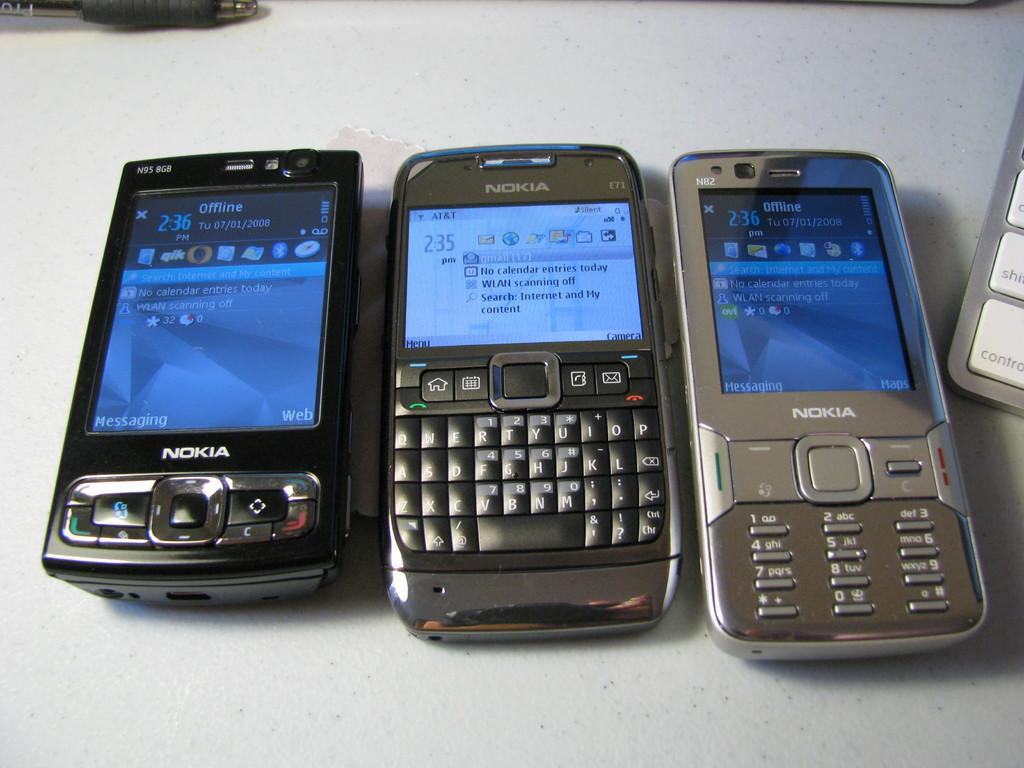Provide a one-sentence caption for the provided image. three nokia phones side by side on a white background next to a keyboard. 